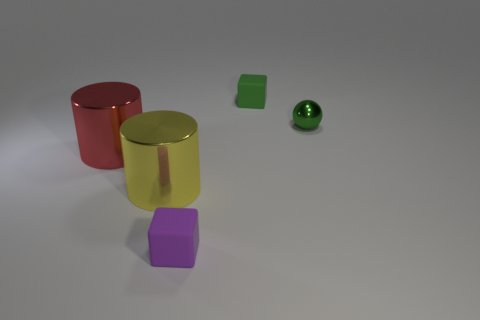Add 1 rubber things. How many objects exist? 6 Subtract all cubes. How many objects are left? 3 Subtract all red shiny cylinders. Subtract all yellow spheres. How many objects are left? 4 Add 4 red metallic cylinders. How many red metallic cylinders are left? 5 Add 5 large objects. How many large objects exist? 7 Subtract 0 brown balls. How many objects are left? 5 